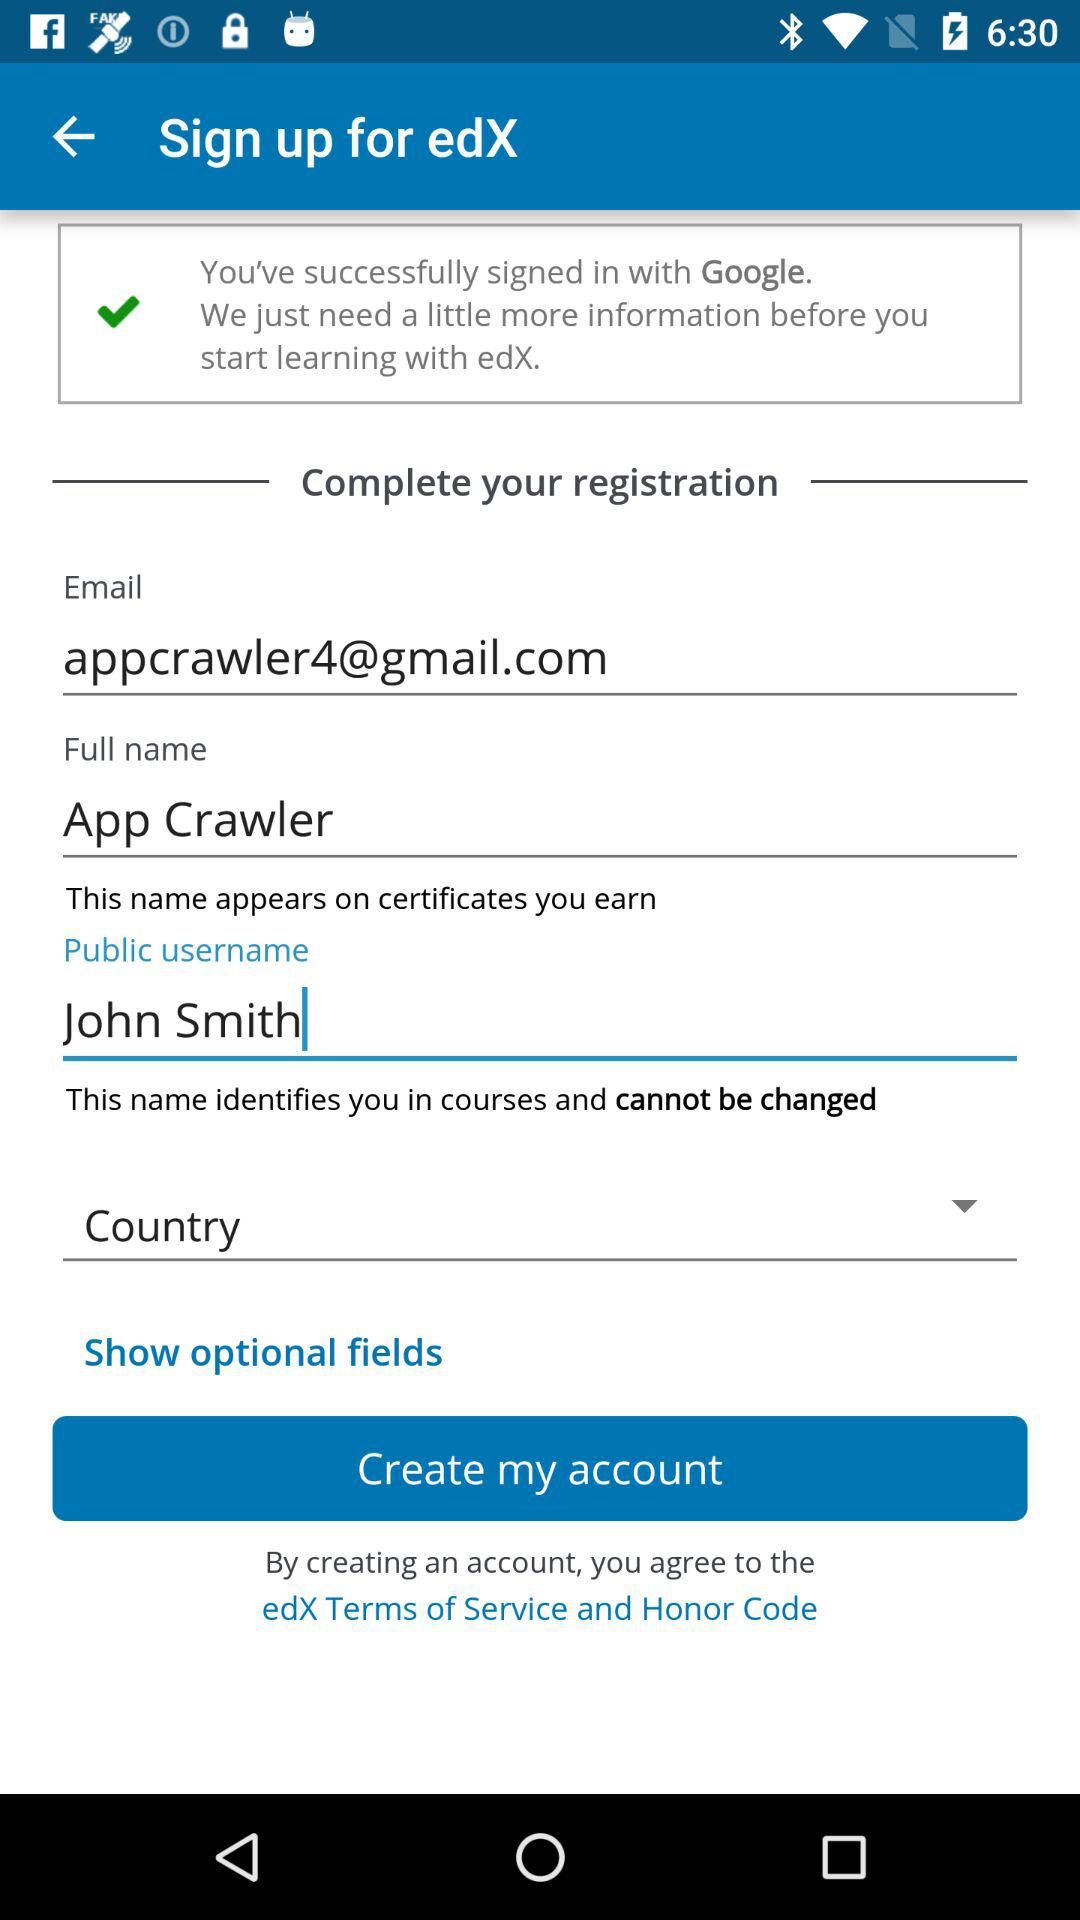What is the public username? The public username is John Smith. 